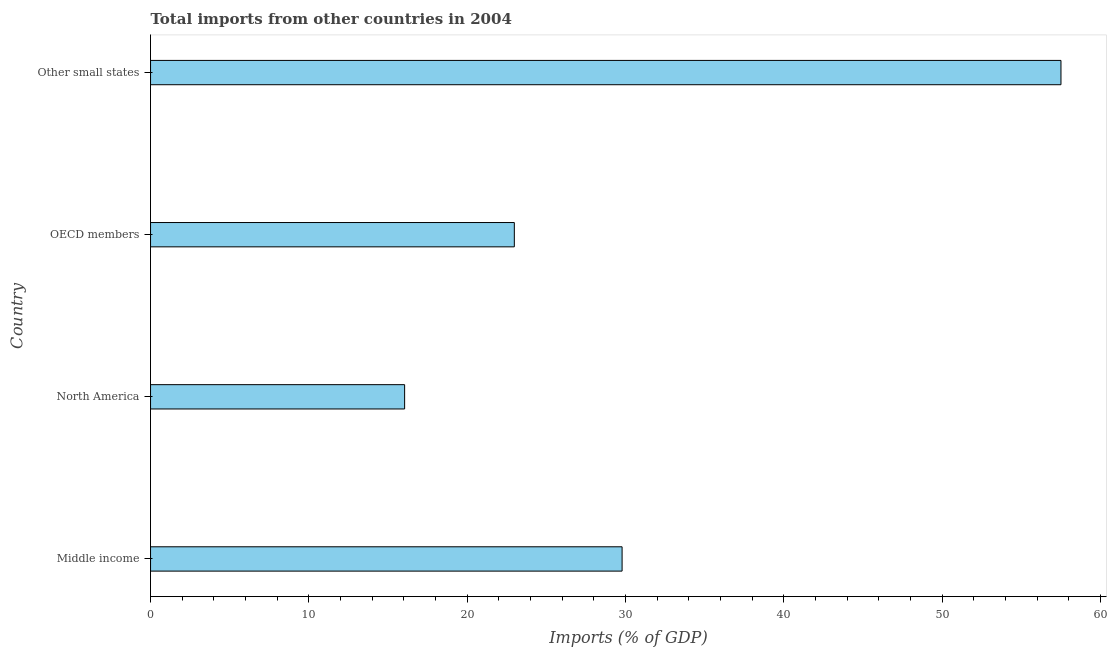What is the title of the graph?
Keep it short and to the point. Total imports from other countries in 2004. What is the label or title of the X-axis?
Offer a very short reply. Imports (% of GDP). What is the total imports in OECD members?
Provide a succinct answer. 22.98. Across all countries, what is the maximum total imports?
Make the answer very short. 57.5. Across all countries, what is the minimum total imports?
Give a very brief answer. 16.05. In which country was the total imports maximum?
Offer a terse response. Other small states. In which country was the total imports minimum?
Give a very brief answer. North America. What is the sum of the total imports?
Make the answer very short. 126.3. What is the difference between the total imports in OECD members and Other small states?
Offer a very short reply. -34.52. What is the average total imports per country?
Provide a short and direct response. 31.58. What is the median total imports?
Provide a succinct answer. 26.38. In how many countries, is the total imports greater than 42 %?
Your answer should be very brief. 1. Is the total imports in Middle income less than that in Other small states?
Offer a very short reply. Yes. What is the difference between the highest and the second highest total imports?
Provide a succinct answer. 27.72. Is the sum of the total imports in Middle income and OECD members greater than the maximum total imports across all countries?
Your answer should be compact. No. What is the difference between the highest and the lowest total imports?
Make the answer very short. 41.45. How many bars are there?
Offer a terse response. 4. Are all the bars in the graph horizontal?
Your answer should be very brief. Yes. What is the difference between two consecutive major ticks on the X-axis?
Your answer should be compact. 10. Are the values on the major ticks of X-axis written in scientific E-notation?
Provide a succinct answer. No. What is the Imports (% of GDP) of Middle income?
Your response must be concise. 29.78. What is the Imports (% of GDP) in North America?
Your response must be concise. 16.05. What is the Imports (% of GDP) of OECD members?
Give a very brief answer. 22.98. What is the Imports (% of GDP) in Other small states?
Make the answer very short. 57.5. What is the difference between the Imports (% of GDP) in Middle income and North America?
Provide a succinct answer. 13.73. What is the difference between the Imports (% of GDP) in Middle income and OECD members?
Keep it short and to the point. 6.81. What is the difference between the Imports (% of GDP) in Middle income and Other small states?
Your response must be concise. -27.72. What is the difference between the Imports (% of GDP) in North America and OECD members?
Give a very brief answer. -6.93. What is the difference between the Imports (% of GDP) in North America and Other small states?
Keep it short and to the point. -41.45. What is the difference between the Imports (% of GDP) in OECD members and Other small states?
Keep it short and to the point. -34.52. What is the ratio of the Imports (% of GDP) in Middle income to that in North America?
Your response must be concise. 1.86. What is the ratio of the Imports (% of GDP) in Middle income to that in OECD members?
Provide a succinct answer. 1.3. What is the ratio of the Imports (% of GDP) in Middle income to that in Other small states?
Ensure brevity in your answer.  0.52. What is the ratio of the Imports (% of GDP) in North America to that in OECD members?
Keep it short and to the point. 0.7. What is the ratio of the Imports (% of GDP) in North America to that in Other small states?
Offer a very short reply. 0.28. 